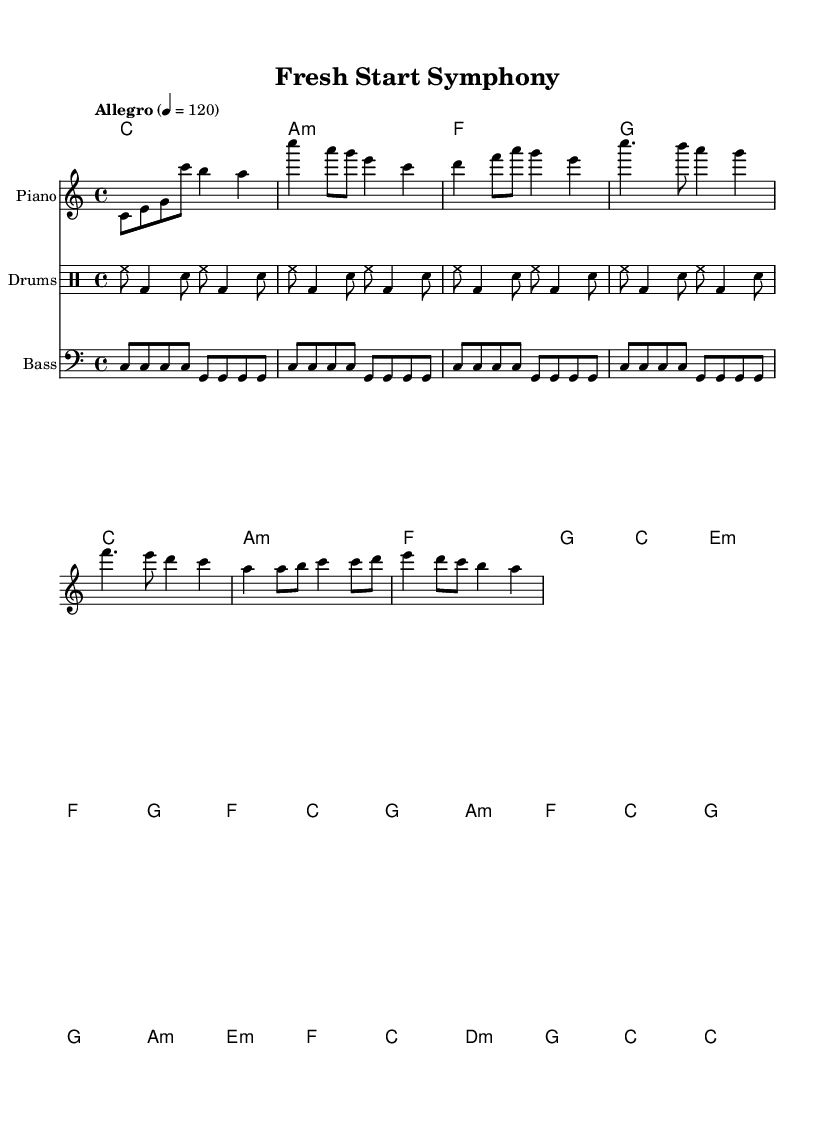What is the key signature of this music? The key signature indicates C major, which has no sharps or flats. This can be determined by looking at the key signature section of the sheet music where the key is indicated.
Answer: C major What is the time signature of the piece? The time signature is written as 4/4 at the beginning of the music, indicating there are four beats in each measure.
Answer: 4/4 What is the tempo marking for the piece? The tempo marking is located near the top of the score, stating "Allegro" with a metronome marking of 120 beats per minute. This means the piece should be played quickly and lively.
Answer: Allegro, 120 How many measures are in the chorus section? The chorus section contains a total of 8 measures. To find this, you would count all the measures that are distinctly marked in the chorus text.
Answer: 8 What is the dynamic marking at the beginning of the score? The dynamic marking at the beginning of the score is not explicitly mentioned in the provided data, but a typical marking for upbeat music like this is often "mf" (mezzo-forte) or similar for a lively feel. This would allow for reasonable inference based on the style and feel of the piece. However, as this specific detail was not present, this general answer is provided.
Answer: (implied dynamic) What type of harmony is primarily used throughout the piece? The harmony section shows the use of major and minor chords, with a combination of triads and seventh chords prevalent in popular music styles. The chord structure in the provided harmonies indicates a mix of both.
Answer: Major and minor chords What is the theme reflected in the lyrics of the piece? The lyrics reflect themes of new beginnings and embracing change, as seen in lines like “Step – ping out in – to the light, leav – ing old sha – dows be – hind,” which indicates moving forward from past difficulties. This thematic content is common in pop soundtracks about second chances.
Answer: New beginnings and change 